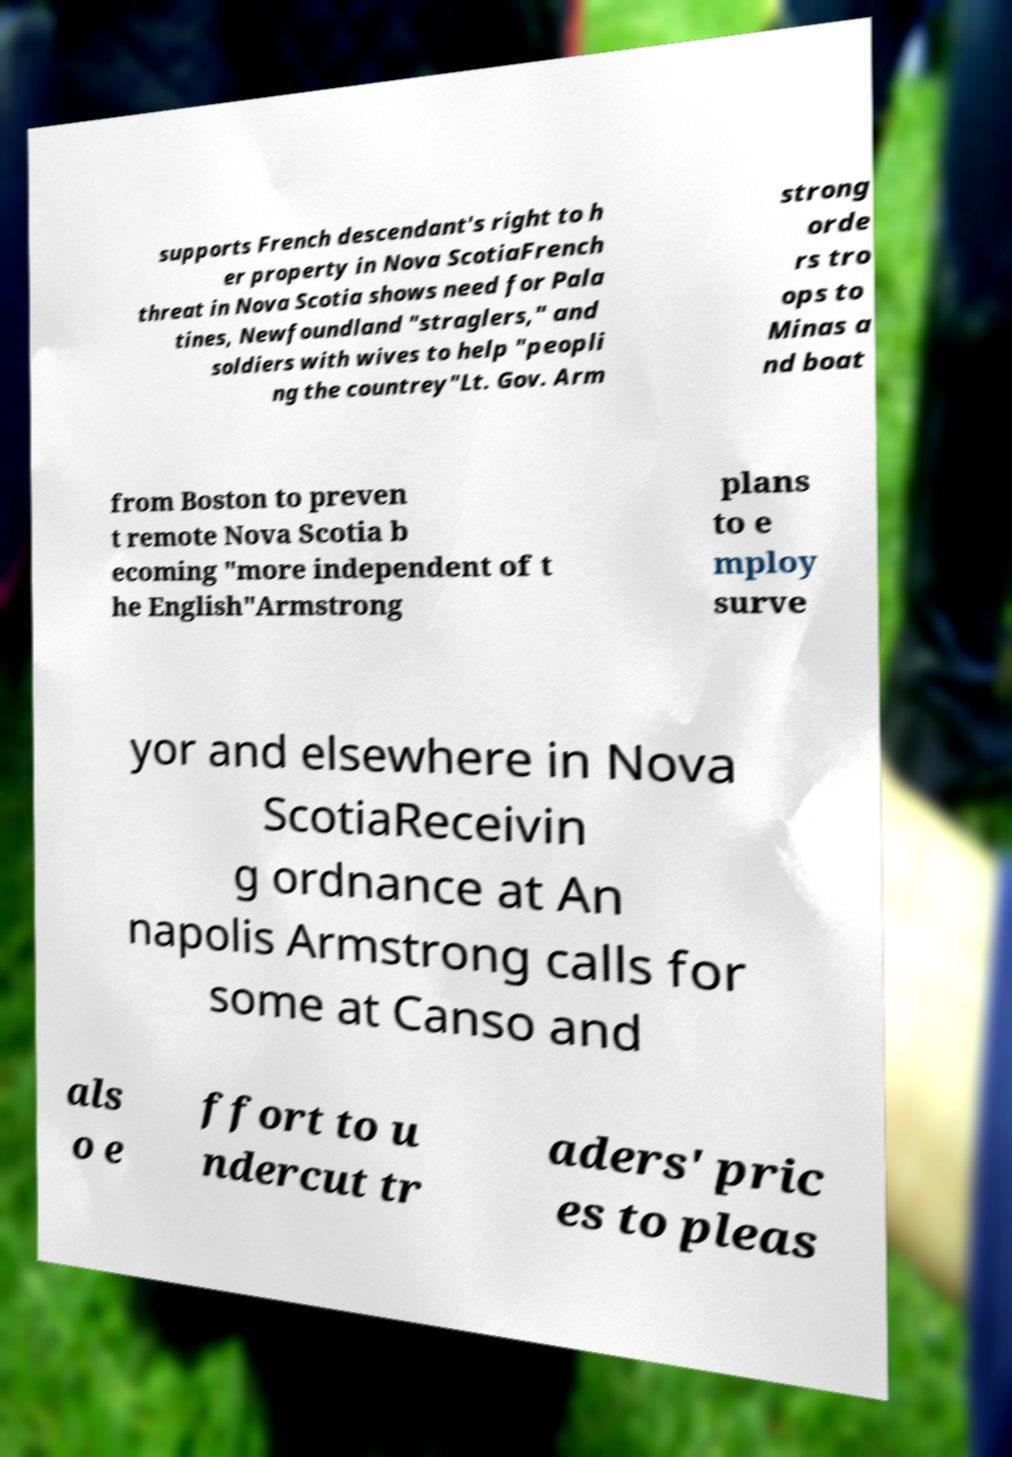Can you read and provide the text displayed in the image?This photo seems to have some interesting text. Can you extract and type it out for me? supports French descendant's right to h er property in Nova ScotiaFrench threat in Nova Scotia shows need for Pala tines, Newfoundland "straglers," and soldiers with wives to help "peopli ng the countrey"Lt. Gov. Arm strong orde rs tro ops to Minas a nd boat from Boston to preven t remote Nova Scotia b ecoming "more independent of t he English"Armstrong plans to e mploy surve yor and elsewhere in Nova ScotiaReceivin g ordnance at An napolis Armstrong calls for some at Canso and als o e ffort to u ndercut tr aders' pric es to pleas 